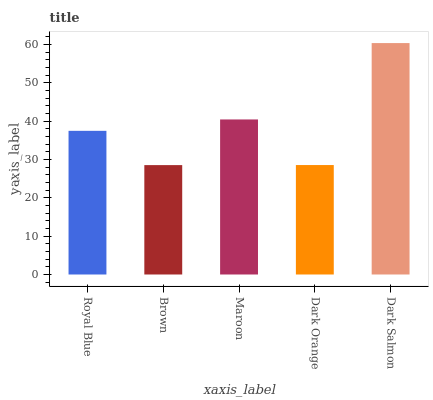Is Brown the minimum?
Answer yes or no. Yes. Is Dark Salmon the maximum?
Answer yes or no. Yes. Is Maroon the minimum?
Answer yes or no. No. Is Maroon the maximum?
Answer yes or no. No. Is Maroon greater than Brown?
Answer yes or no. Yes. Is Brown less than Maroon?
Answer yes or no. Yes. Is Brown greater than Maroon?
Answer yes or no. No. Is Maroon less than Brown?
Answer yes or no. No. Is Royal Blue the high median?
Answer yes or no. Yes. Is Royal Blue the low median?
Answer yes or no. Yes. Is Maroon the high median?
Answer yes or no. No. Is Brown the low median?
Answer yes or no. No. 